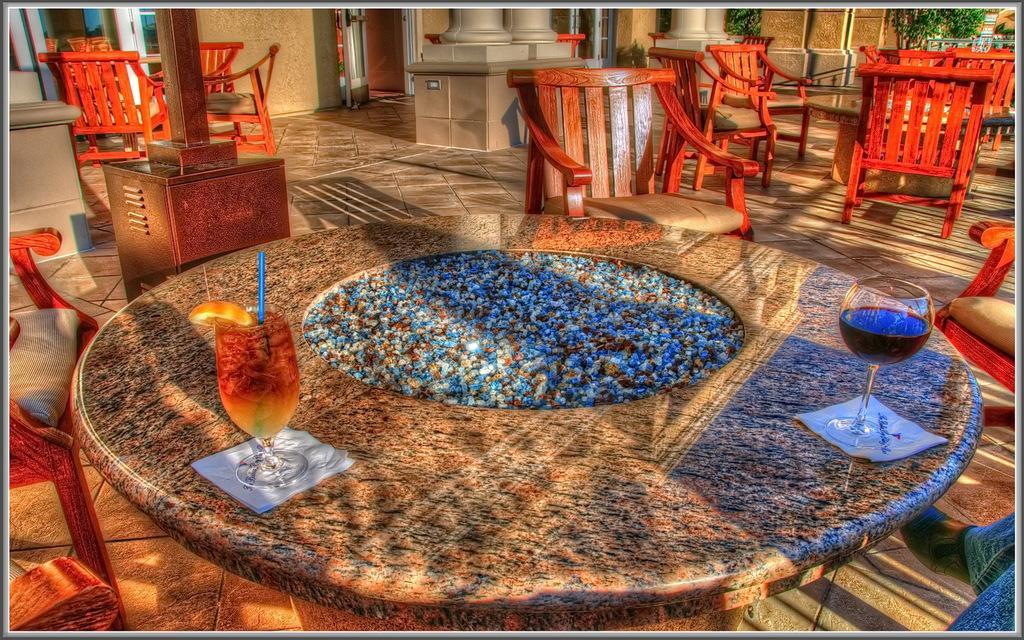Please provide a concise description of this image. This picture is taken inside a restaurant and it is sunny. In this image, on the left side, we can see two chairs. In the right side corner, we can see the legs of a person. On the right side, we can see a chair. In the middle of the image, we can see a table, on that table, we can see two glasses with drinks, straw and tissues. In the background, we can see some tables, chairs, pillars, glass window, plants, glass doors. 